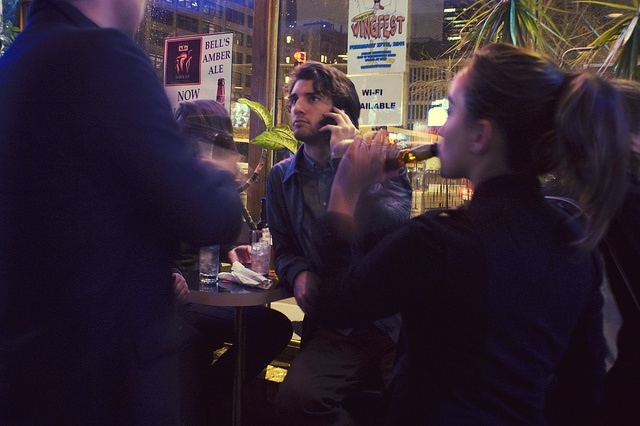Describe the objects in this image and their specific colors. I can see people in beige, black, and purple tones, people in beige, black, navy, and purple tones, people in beige, black, brown, navy, and purple tones, people in beige, black, navy, and purple tones, and dining table in beige, black, and purple tones in this image. 